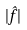<formula> <loc_0><loc_0><loc_500><loc_500>| \hat { f } |</formula> 